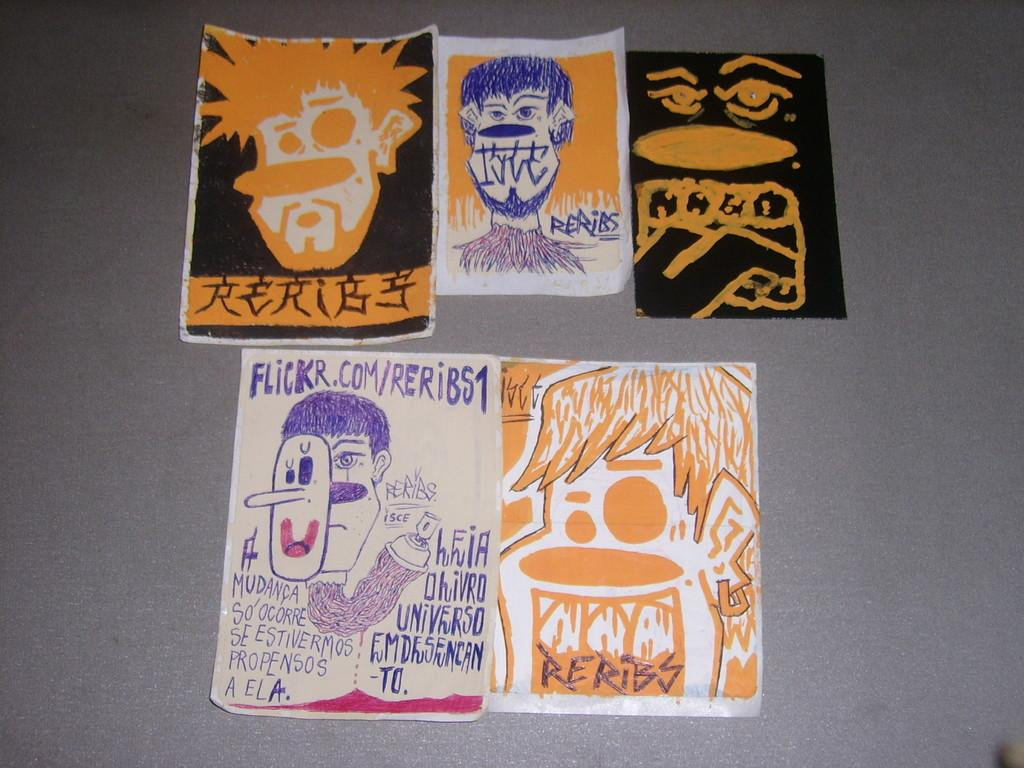What can be seen on the papers in the image? There are drawings on the papers. Where are the papers located in the image? The papers are on an object. What type of cream can be seen on the drawings in the image? There is no cream present on the drawings in the image. Can you hear the sound of the drawings in the image? The image is visual, and there is no sound associated with the drawings. 